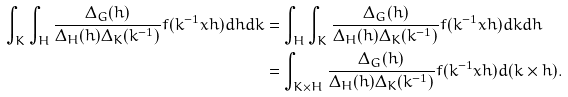<formula> <loc_0><loc_0><loc_500><loc_500>\int _ { K } \int _ { H } \frac { \Delta _ { G } ( h ) } { \Delta _ { H } ( h ) \Delta _ { K } ( k ^ { - 1 } ) } f ( k ^ { - 1 } x h ) d h d k & = \int _ { H } \int _ { K } \frac { \Delta _ { G } ( h ) } { \Delta _ { H } ( h ) \Delta _ { K } ( k ^ { - 1 } ) } f ( k ^ { - 1 } x h ) d k d h \\ & = \int _ { K \times H } \frac { \Delta _ { G } ( h ) } { \Delta _ { H } ( h ) \Delta _ { K } ( k ^ { - 1 } ) } f ( k ^ { - 1 } x h ) d ( k \times h ) .</formula> 